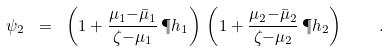Convert formula to latex. <formula><loc_0><loc_0><loc_500><loc_500>\psi _ { 2 } \ = \ \left ( 1 + \frac { \mu _ { 1 } { - } \bar { \mu } _ { 1 } } { \zeta { - } \mu _ { 1 } } \, \P h _ { 1 } \right ) \, \left ( 1 + \frac { \mu _ { 2 } { - } \bar { \mu } _ { 2 } } { \zeta { - } \mu _ { 2 } } \, \P h _ { 2 } \right ) \quad .</formula> 